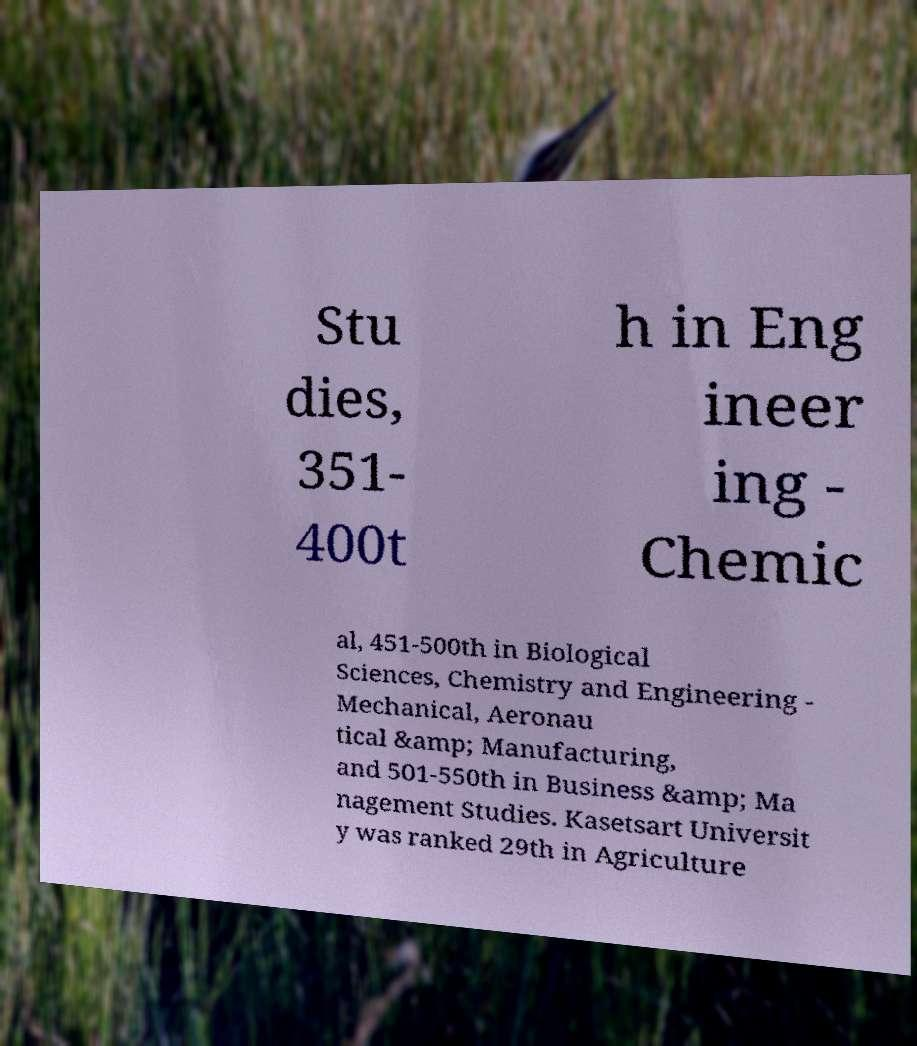Could you assist in decoding the text presented in this image and type it out clearly? Stu dies, 351- 400t h in Eng ineer ing - Chemic al, 451-500th in Biological Sciences, Chemistry and Engineering - Mechanical, Aeronau tical &amp; Manufacturing, and 501-550th in Business &amp; Ma nagement Studies. Kasetsart Universit y was ranked 29th in Agriculture 